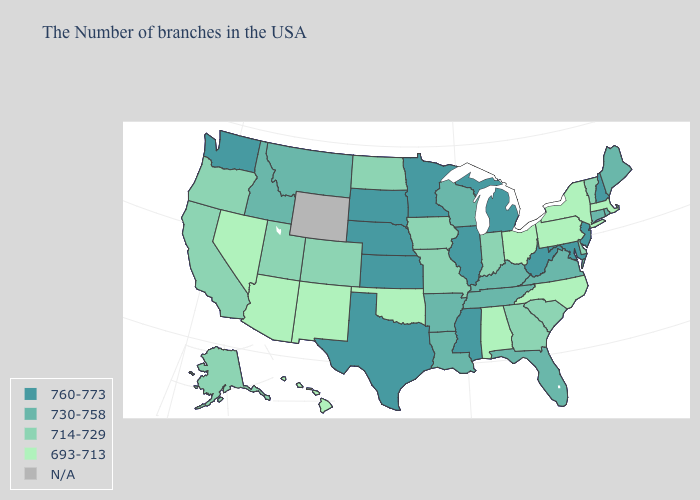Is the legend a continuous bar?
Give a very brief answer. No. Does the first symbol in the legend represent the smallest category?
Quick response, please. No. Among the states that border Tennessee , which have the highest value?
Short answer required. Mississippi. Which states hav the highest value in the West?
Write a very short answer. Washington. What is the highest value in the USA?
Quick response, please. 760-773. What is the lowest value in the West?
Concise answer only. 693-713. Which states have the lowest value in the USA?
Write a very short answer. Massachusetts, New York, Pennsylvania, North Carolina, Ohio, Alabama, Oklahoma, New Mexico, Arizona, Nevada, Hawaii. Is the legend a continuous bar?
Be succinct. No. What is the highest value in the USA?
Concise answer only. 760-773. Does Utah have the lowest value in the USA?
Be succinct. No. How many symbols are there in the legend?
Be succinct. 5. Name the states that have a value in the range 714-729?
Be succinct. Vermont, Delaware, South Carolina, Georgia, Indiana, Missouri, Iowa, North Dakota, Colorado, Utah, California, Oregon, Alaska. Which states hav the highest value in the South?
Quick response, please. Maryland, West Virginia, Mississippi, Texas. What is the value of Nevada?
Keep it brief. 693-713. 